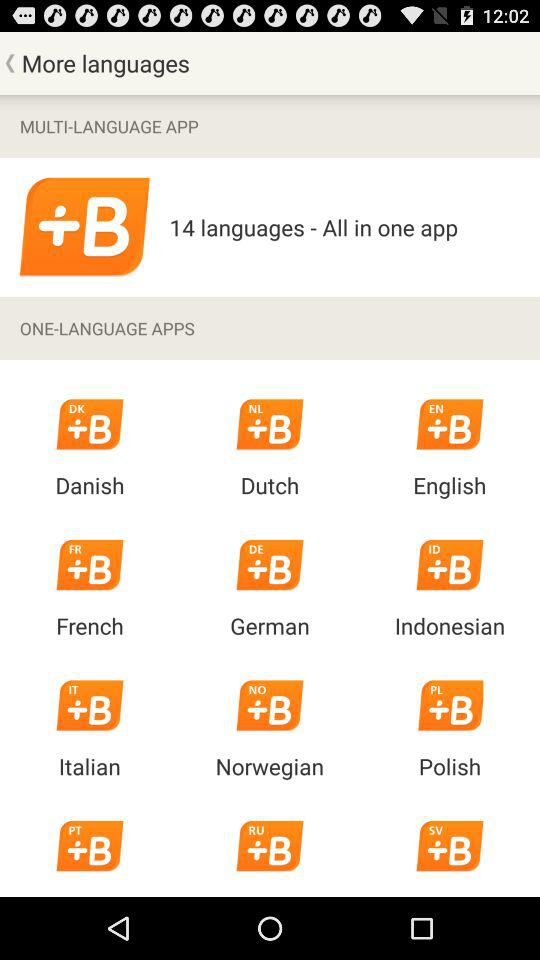How many languages are there? There are 14 languages. 